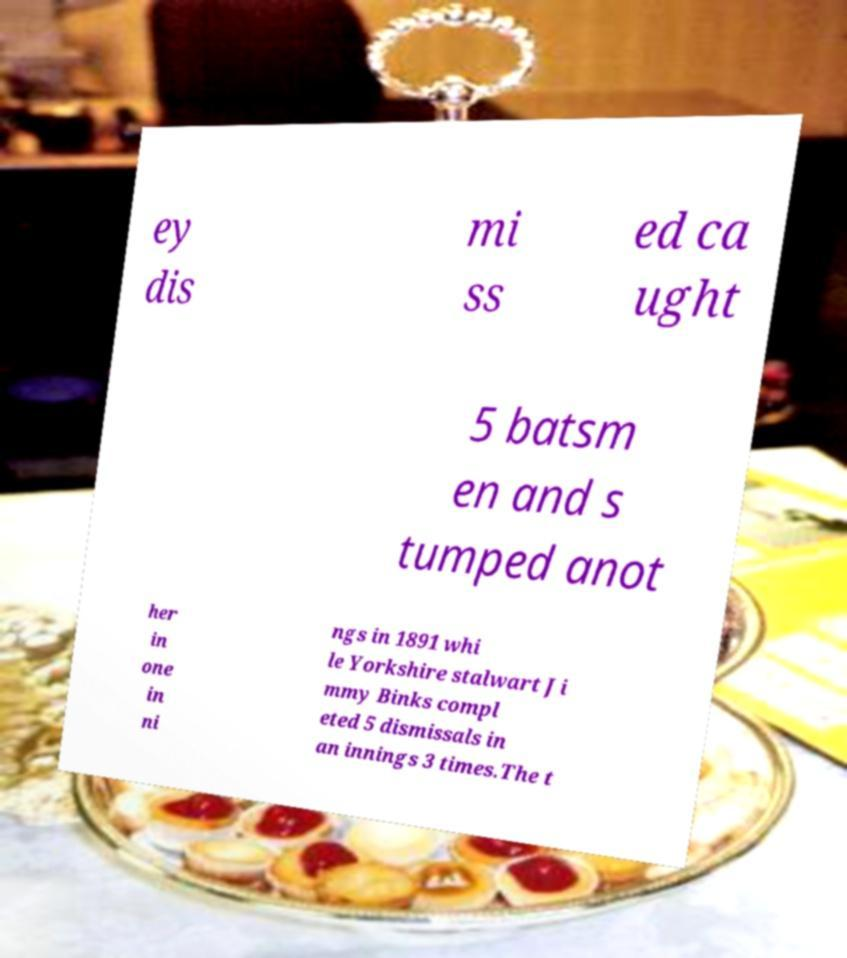Please read and relay the text visible in this image. What does it say? ey dis mi ss ed ca ught 5 batsm en and s tumped anot her in one in ni ngs in 1891 whi le Yorkshire stalwart Ji mmy Binks compl eted 5 dismissals in an innings 3 times.The t 